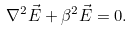<formula> <loc_0><loc_0><loc_500><loc_500>\nabla ^ { 2 } \vec { E } + \beta ^ { 2 } \vec { E } & = 0 .</formula> 